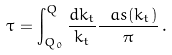Convert formula to latex. <formula><loc_0><loc_0><loc_500><loc_500>\tau = \int _ { Q _ { 0 } } ^ { Q } \frac { d k _ { t } } { k _ { t } } \frac { \ a s ( k _ { t } ) } { \pi } \, .</formula> 